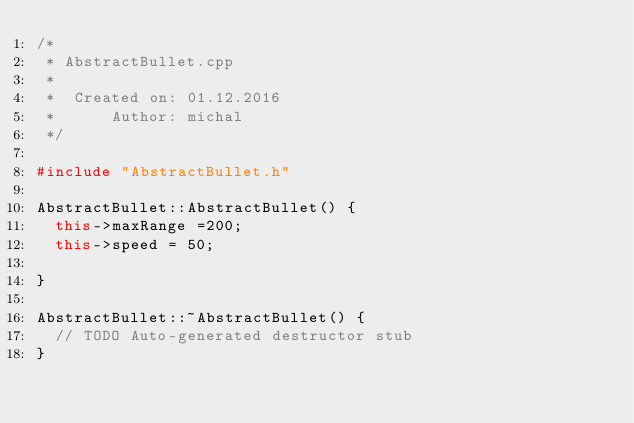<code> <loc_0><loc_0><loc_500><loc_500><_C++_>/*
 * AbstractBullet.cpp
 *
 *  Created on: 01.12.2016
 *      Author: michal
 */

#include "AbstractBullet.h"

AbstractBullet::AbstractBullet() {
	this->maxRange =200;
	this->speed = 50;

}

AbstractBullet::~AbstractBullet() {
	// TODO Auto-generated destructor stub
}

</code> 